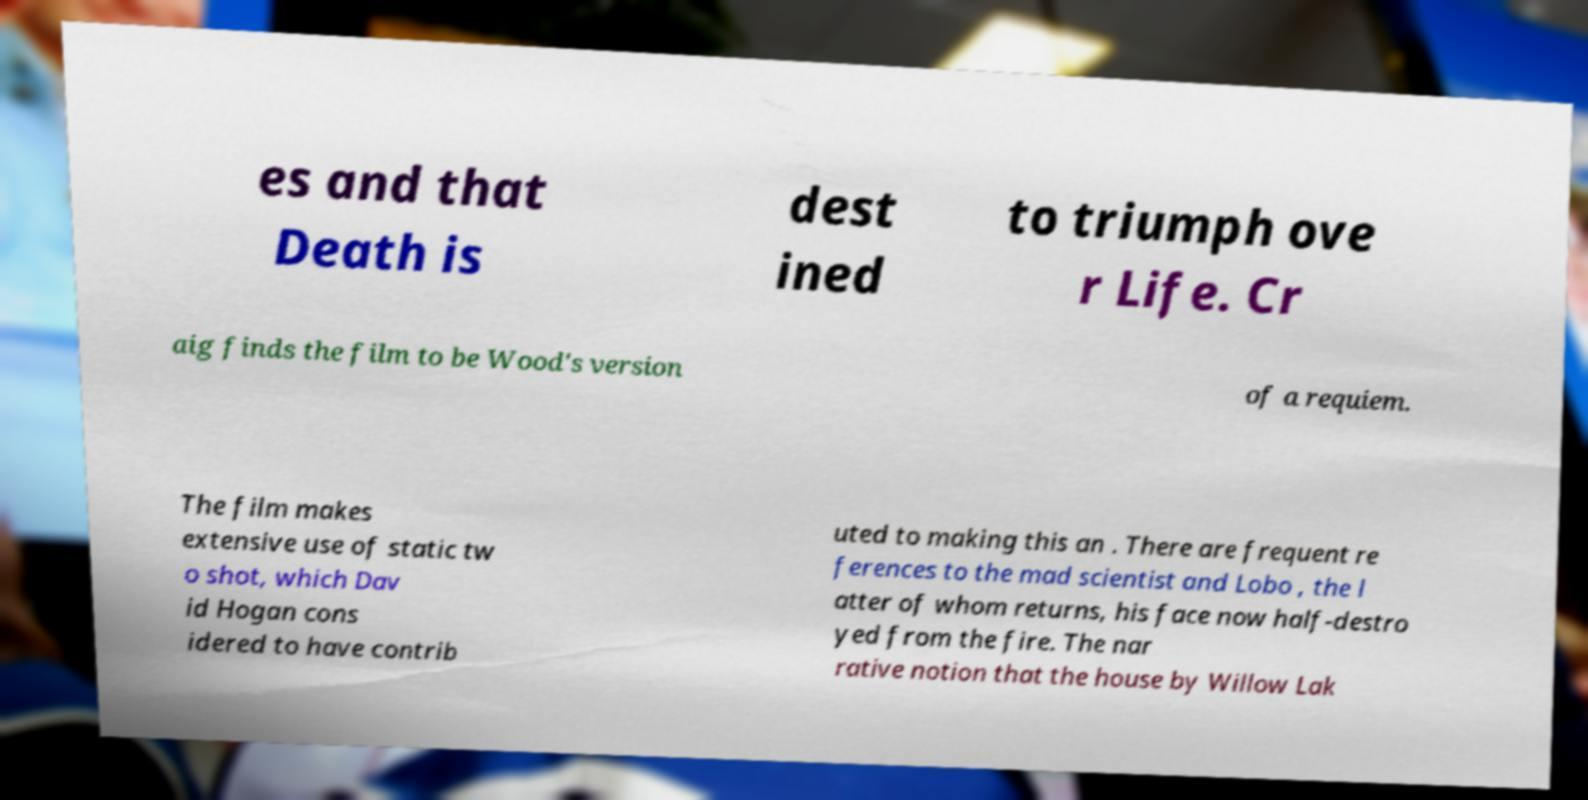Could you assist in decoding the text presented in this image and type it out clearly? es and that Death is dest ined to triumph ove r Life. Cr aig finds the film to be Wood's version of a requiem. The film makes extensive use of static tw o shot, which Dav id Hogan cons idered to have contrib uted to making this an . There are frequent re ferences to the mad scientist and Lobo , the l atter of whom returns, his face now half-destro yed from the fire. The nar rative notion that the house by Willow Lak 